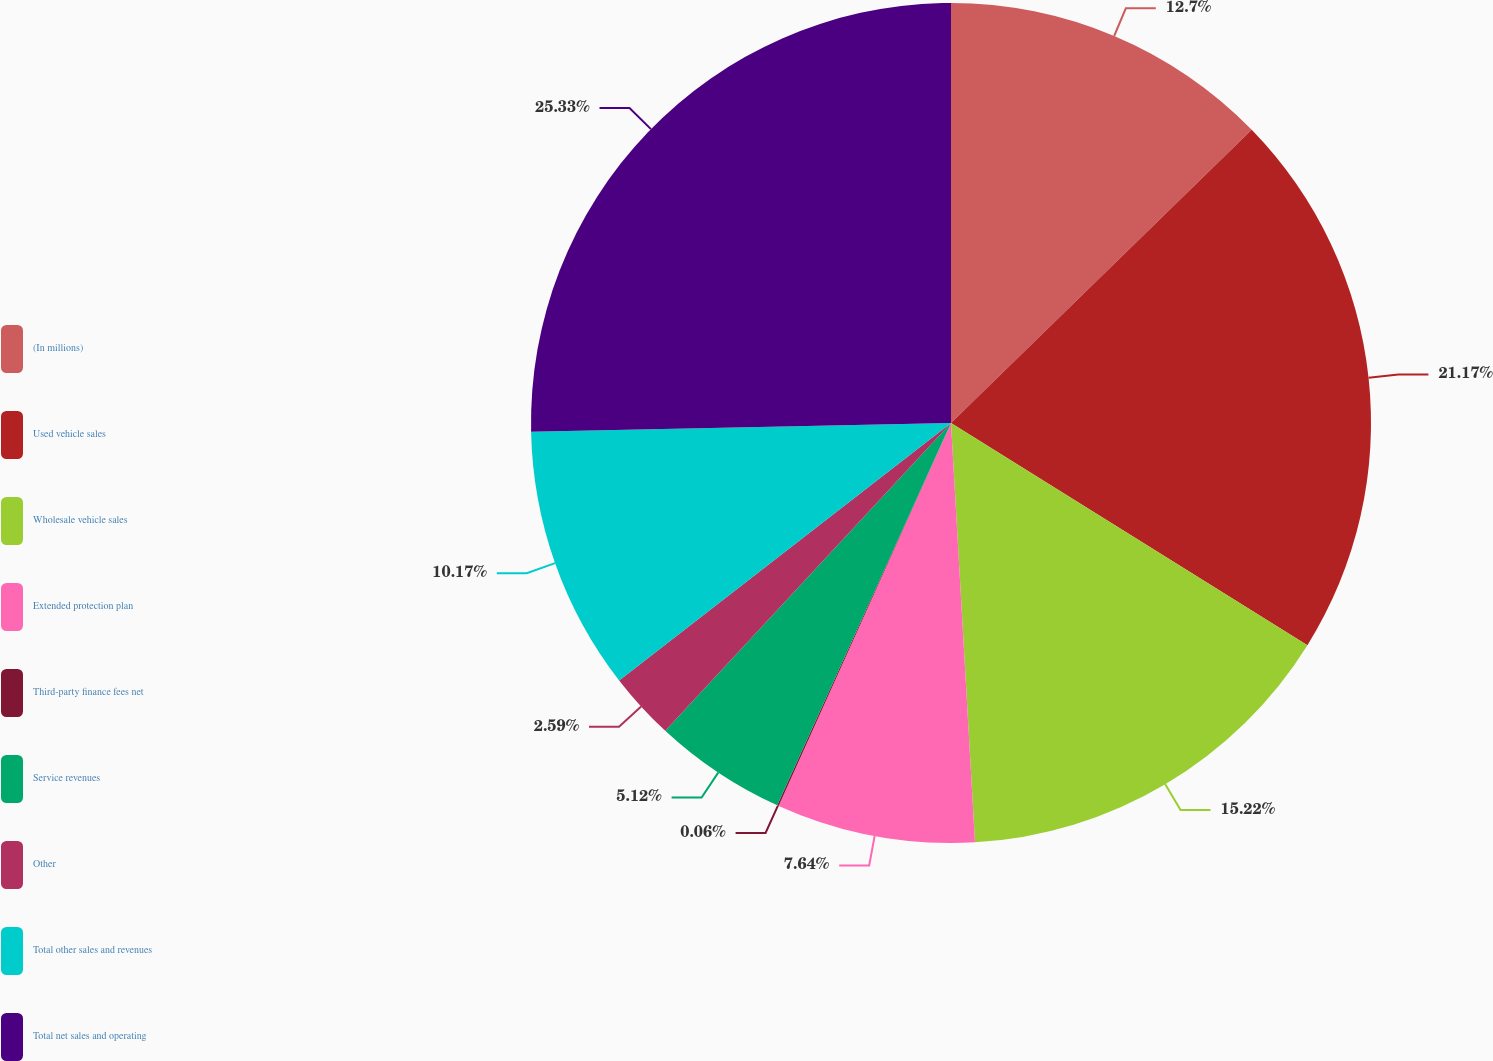Convert chart. <chart><loc_0><loc_0><loc_500><loc_500><pie_chart><fcel>(In millions)<fcel>Used vehicle sales<fcel>Wholesale vehicle sales<fcel>Extended protection plan<fcel>Third-party finance fees net<fcel>Service revenues<fcel>Other<fcel>Total other sales and revenues<fcel>Total net sales and operating<nl><fcel>12.7%<fcel>21.17%<fcel>15.22%<fcel>7.64%<fcel>0.06%<fcel>5.12%<fcel>2.59%<fcel>10.17%<fcel>25.33%<nl></chart> 